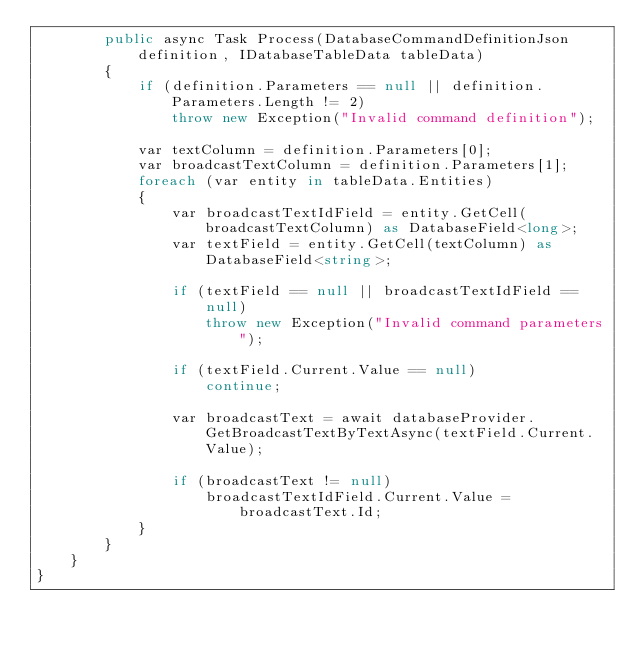Convert code to text. <code><loc_0><loc_0><loc_500><loc_500><_C#_>        public async Task Process(DatabaseCommandDefinitionJson definition, IDatabaseTableData tableData)
        {
            if (definition.Parameters == null || definition.Parameters.Length != 2)
                throw new Exception("Invalid command definition");
            
            var textColumn = definition.Parameters[0];
            var broadcastTextColumn = definition.Parameters[1];
            foreach (var entity in tableData.Entities)
            {
                var broadcastTextIdField = entity.GetCell(broadcastTextColumn) as DatabaseField<long>;
                var textField = entity.GetCell(textColumn) as DatabaseField<string>;

                if (textField == null || broadcastTextIdField == null)
                    throw new Exception("Invalid command parameters");

                if (textField.Current.Value == null)
                    continue;
                
                var broadcastText = await databaseProvider.GetBroadcastTextByTextAsync(textField.Current.Value);
                
                if (broadcastText != null)
                    broadcastTextIdField.Current.Value = broadcastText.Id;
            }
        }
    }
}</code> 